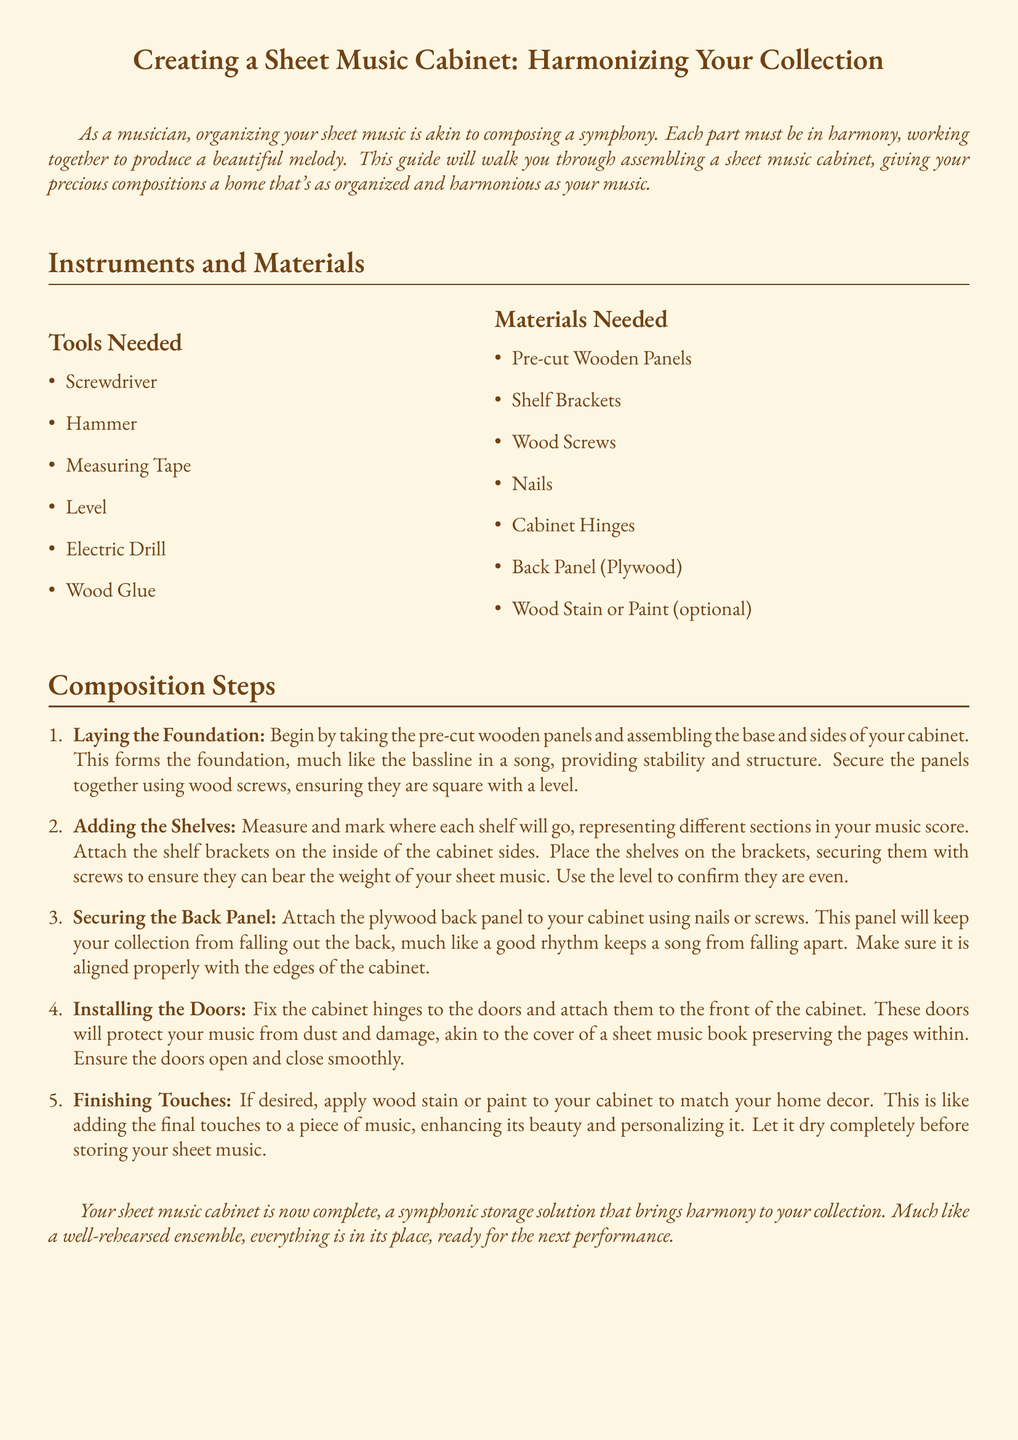what is the first step in creating the cabinet? The first step is laying the foundation by assembling the base and sides of the cabinet.
Answer: Laying the Foundation how many tools are needed for assembly? The document lists six tools required to construct the cabinet.
Answer: Six what materials are required for the doors? The materials needed for the doors include cabinet hinges.
Answer: Cabinet Hinges what is the purpose of the back panel? The back panel keeps your collection from falling out, much like a good rhythm in a song.
Answer: To keep collection secure what should you apply to match the cabinet with home decor? The document suggests applying wood stain or paint to personalize the cabinet.
Answer: Wood Stain or Paint how are the shelves secured to the cabinet? The shelves are secured with screws after being placed on the shelf brackets.
Answer: With screws what analogy is used for installing the doors? Installing the doors is likened to the cover of a sheet music book preserving the pages within.
Answer: Cover of a sheet music book what is the final touch in the assembly process? The final touch is applying wood stain or paint and letting it dry completely.
Answer: Finishing Touches how does the document describe the completed cabinet? The document describes the completed cabinet as a symphonic storage solution.
Answer: Symphonic storage solution 